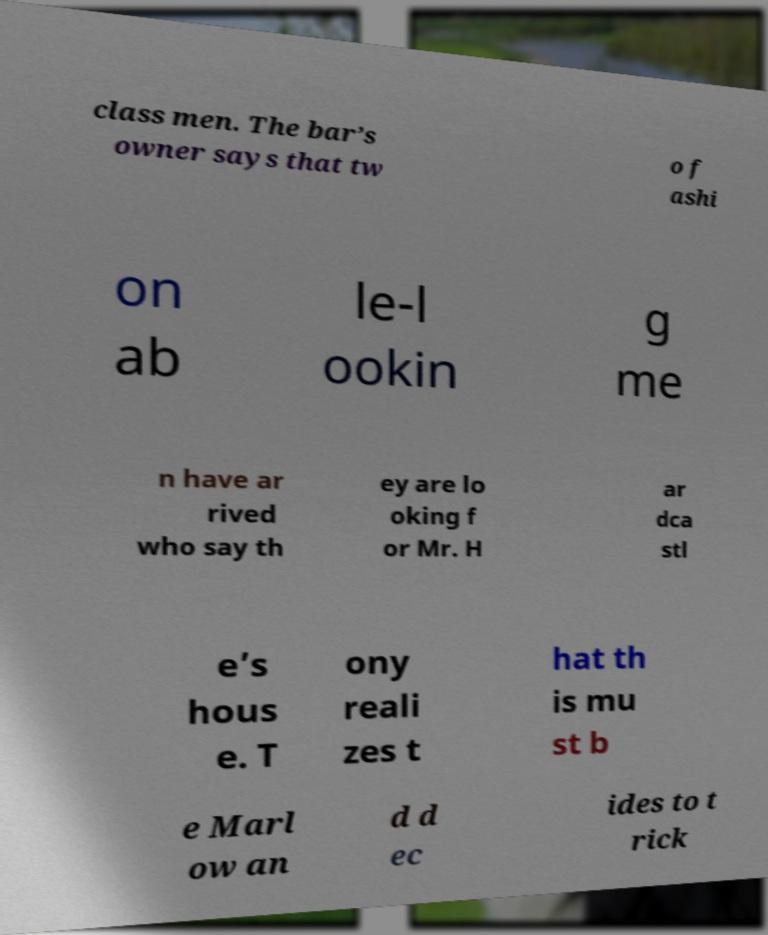What messages or text are displayed in this image? I need them in a readable, typed format. class men. The bar’s owner says that tw o f ashi on ab le-l ookin g me n have ar rived who say th ey are lo oking f or Mr. H ar dca stl e’s hous e. T ony reali zes t hat th is mu st b e Marl ow an d d ec ides to t rick 